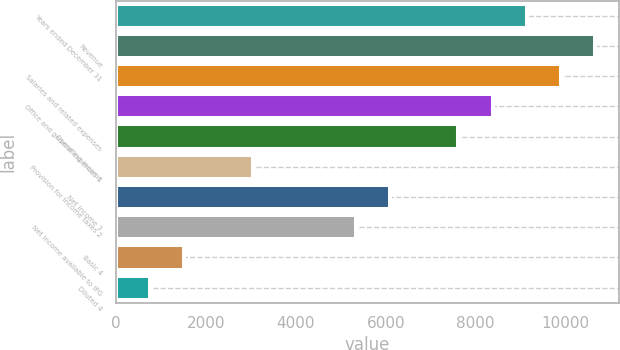<chart> <loc_0><loc_0><loc_500><loc_500><bar_chart><fcel>Years ended December 31<fcel>Revenue<fcel>Salaries and related expenses<fcel>Office and general expenses 1<fcel>Operating income<fcel>Provision for income taxes 2<fcel>Net income 3<fcel>Net income available to IPG<fcel>Basic 4<fcel>Diluted 4<nl><fcel>9136.44<fcel>10659.1<fcel>9897.77<fcel>8375.11<fcel>7613.78<fcel>3045.8<fcel>6091.12<fcel>5329.79<fcel>1523.14<fcel>761.81<nl></chart> 